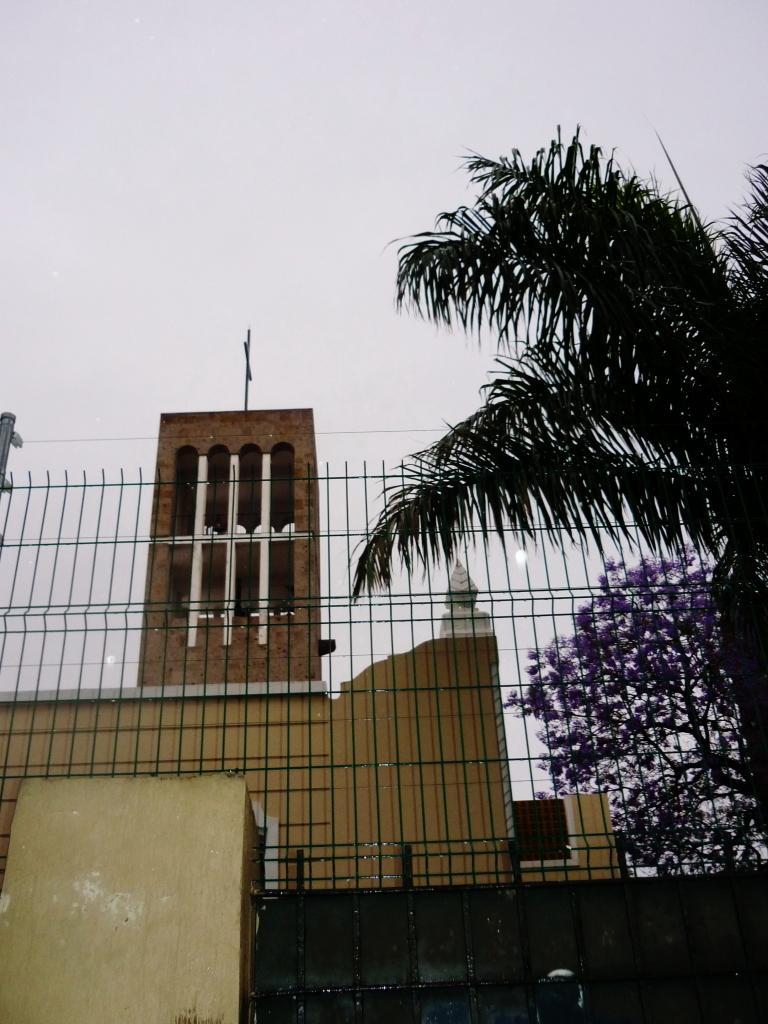Could you give a brief overview of what you see in this image? In this picture in the front there is a wall. In the center there is a black colour fence and there is a tree. In the background there is a building. On the right side there are trees. 